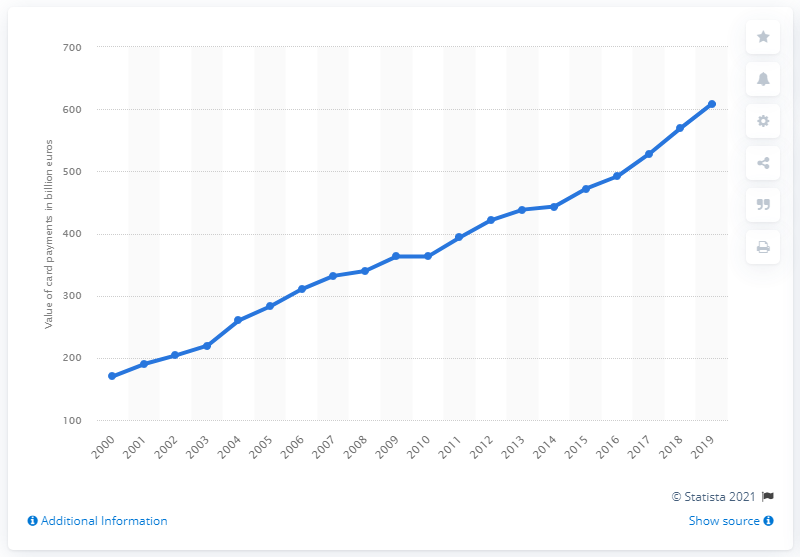Point out several critical features in this image. In France, the total value of card payments between 2000 and 2019 was 608.8 billion euros. 